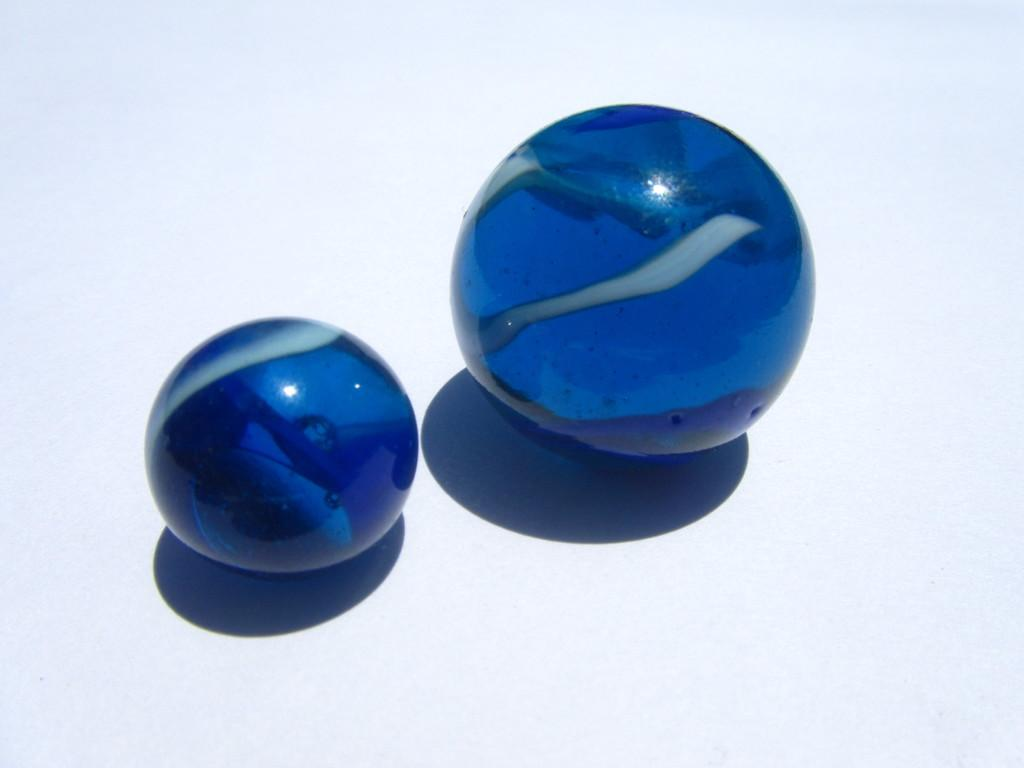What objects are present in the image? There are two blue-colored balls in the image. What is the color of the balls? The balls are blue. What is the color of the background surface in the image? The background surface is white. How much sugar is on the scale in the image? There is no scale or sugar present in the image; it only features two blue-colored balls on a white background. 